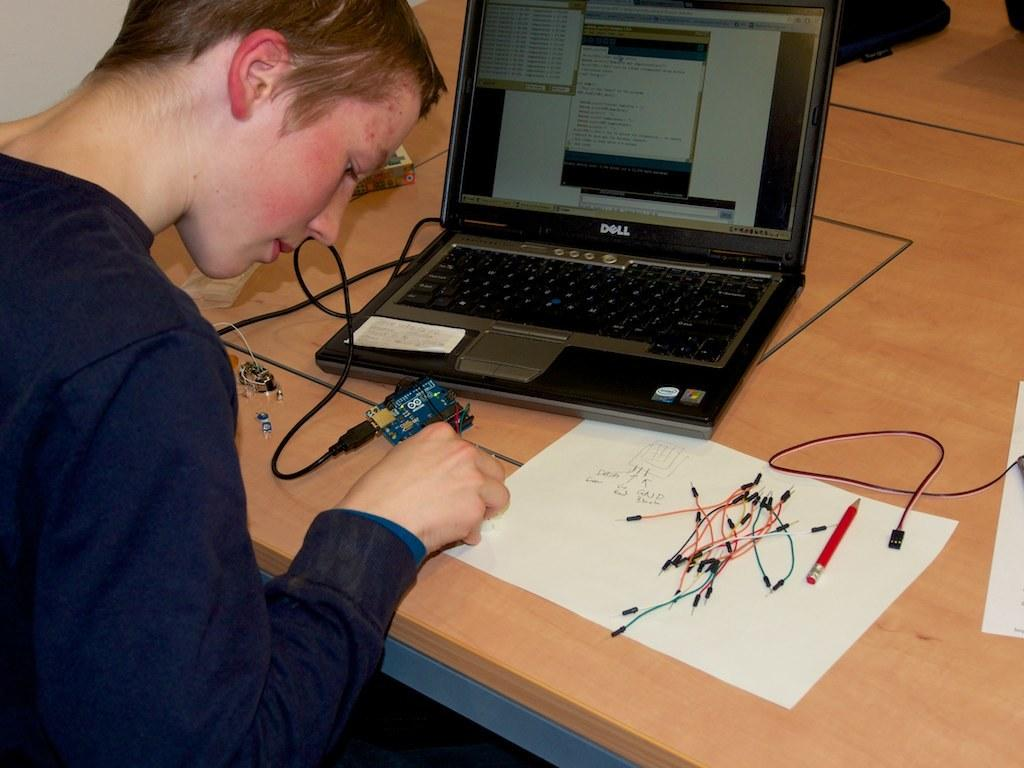What is the person in the image doing? There is a person sitting in the image. What object is in front of the person? There is a laptop in front of the person. What else can be seen in the image besides the person and laptop? Wires, a paper, and a pencil are present in the image. What is the color of the table in the image? The table in the image is brown. What objects are on the table in the image? There are objects on the brown color table in the image. Can you see the person's toe in the image? There is no visible toe in the image; it only shows a person sitting with a laptop and other objects. 